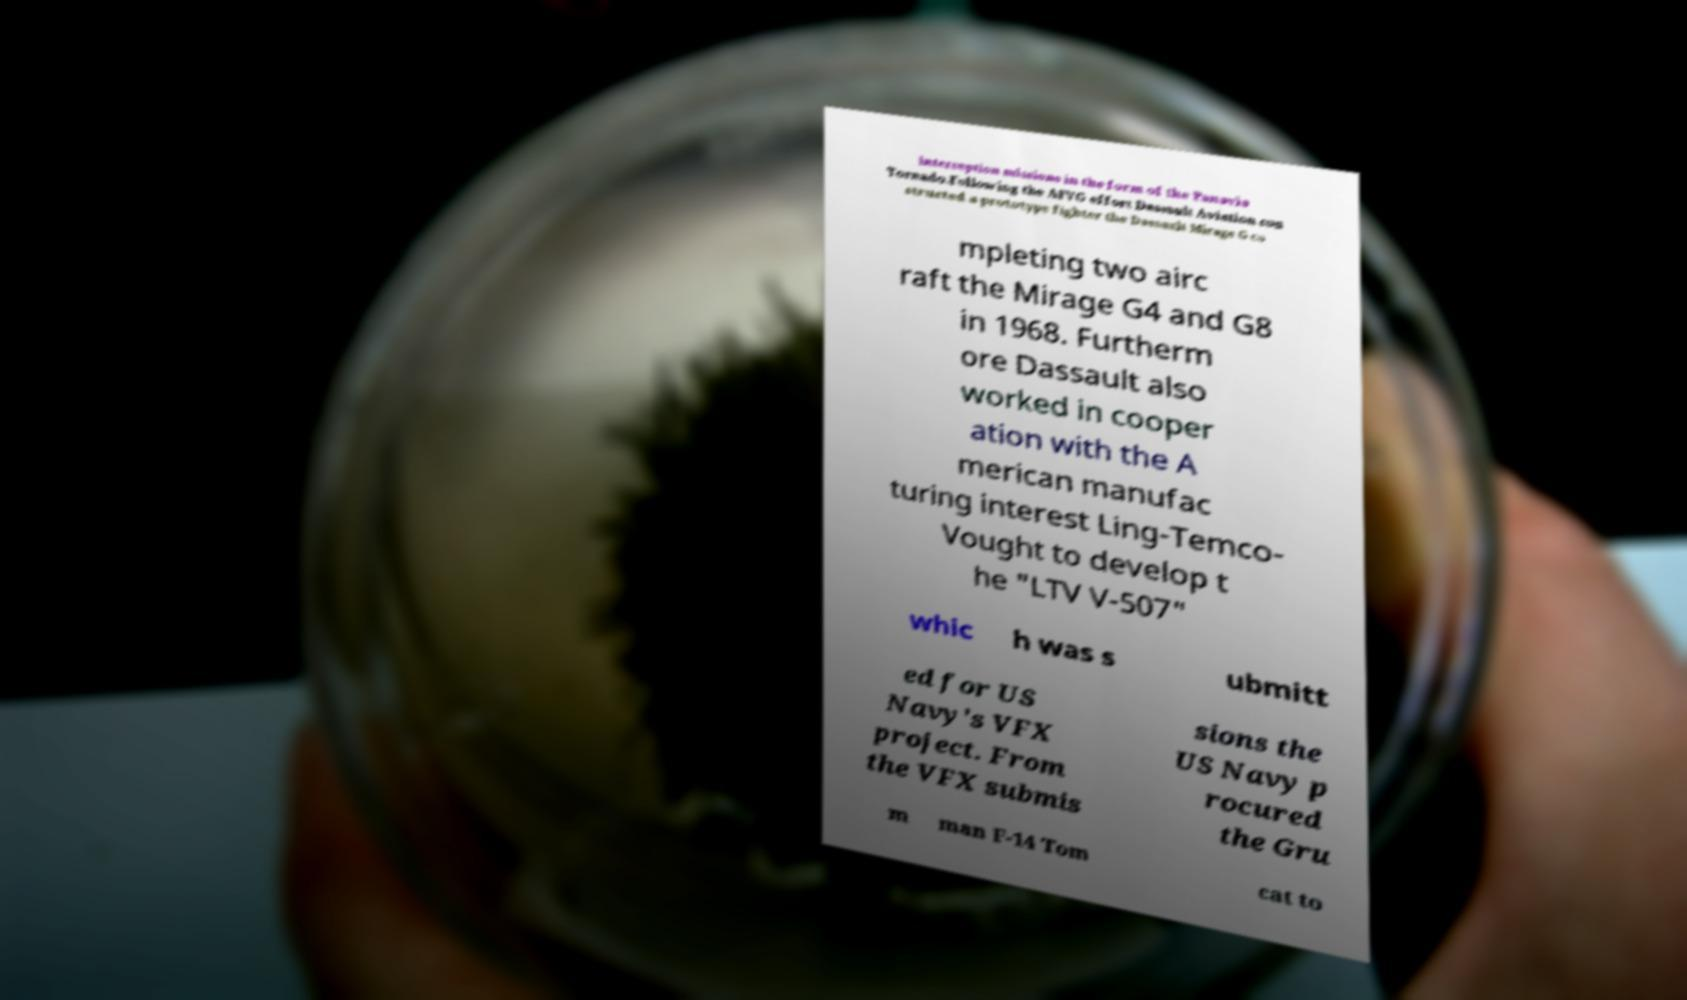There's text embedded in this image that I need extracted. Can you transcribe it verbatim? interception missions in the form of the Panavia Tornado.Following the AFVG effort Dassault Aviation con structed a prototype fighter the Dassault Mirage G co mpleting two airc raft the Mirage G4 and G8 in 1968. Furtherm ore Dassault also worked in cooper ation with the A merican manufac turing interest Ling-Temco- Vought to develop t he "LTV V-507" whic h was s ubmitt ed for US Navy's VFX project. From the VFX submis sions the US Navy p rocured the Gru m man F-14 Tom cat to 